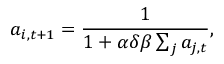Convert formula to latex. <formula><loc_0><loc_0><loc_500><loc_500>a _ { i , t + 1 } = \frac { 1 } { 1 + \alpha \delta \beta \sum _ { j } a _ { j , t } } ,</formula> 